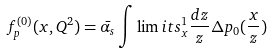<formula> <loc_0><loc_0><loc_500><loc_500>f _ { p } ^ { ( 0 ) } ( x , Q ^ { 2 } ) = \bar { \alpha _ { s } } \int \lim i t s _ { x } ^ { 1 } \frac { d z } { z } \Delta p _ { 0 } ( \frac { x } { z } )</formula> 